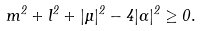<formula> <loc_0><loc_0><loc_500><loc_500>m ^ { 2 } + l ^ { 2 } + | \Upsilon | ^ { 2 } - 4 | \Gamma | ^ { 2 } \geq 0 .</formula> 